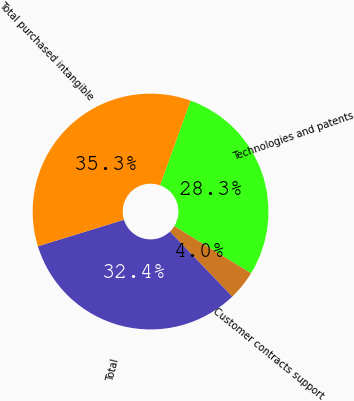Convert chart to OTSL. <chart><loc_0><loc_0><loc_500><loc_500><pie_chart><fcel>Technologies and patents<fcel>Customer contracts support<fcel>Total<fcel>Total purchased intangible<nl><fcel>28.27%<fcel>4.04%<fcel>32.42%<fcel>35.26%<nl></chart> 